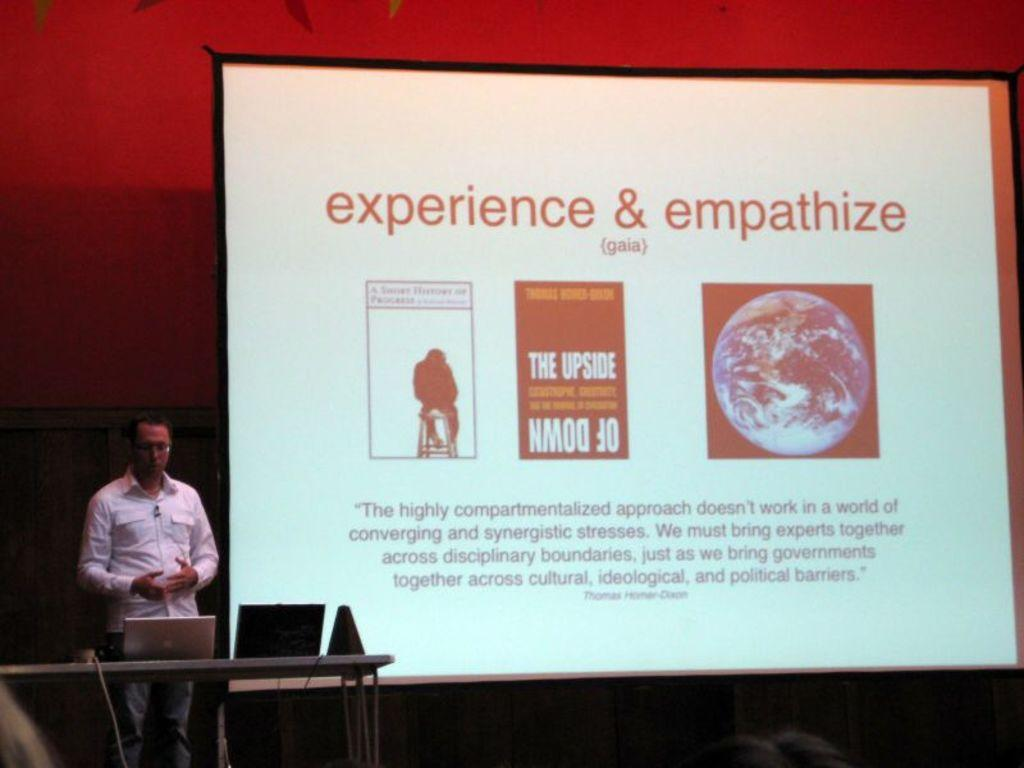<image>
Describe the image concisely. A movie screen that says experience& empathize on it. 